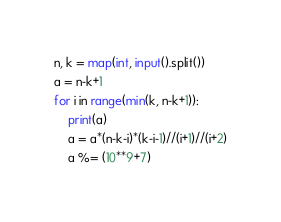<code> <loc_0><loc_0><loc_500><loc_500><_Python_>n, k = map(int, input().split())
a = n-k+1
for i in range(min(k, n-k+1)):
    print(a)
    a = a*(n-k-i)*(k-i-1)//(i+1)//(i+2)
    a %= (10**9+7)</code> 